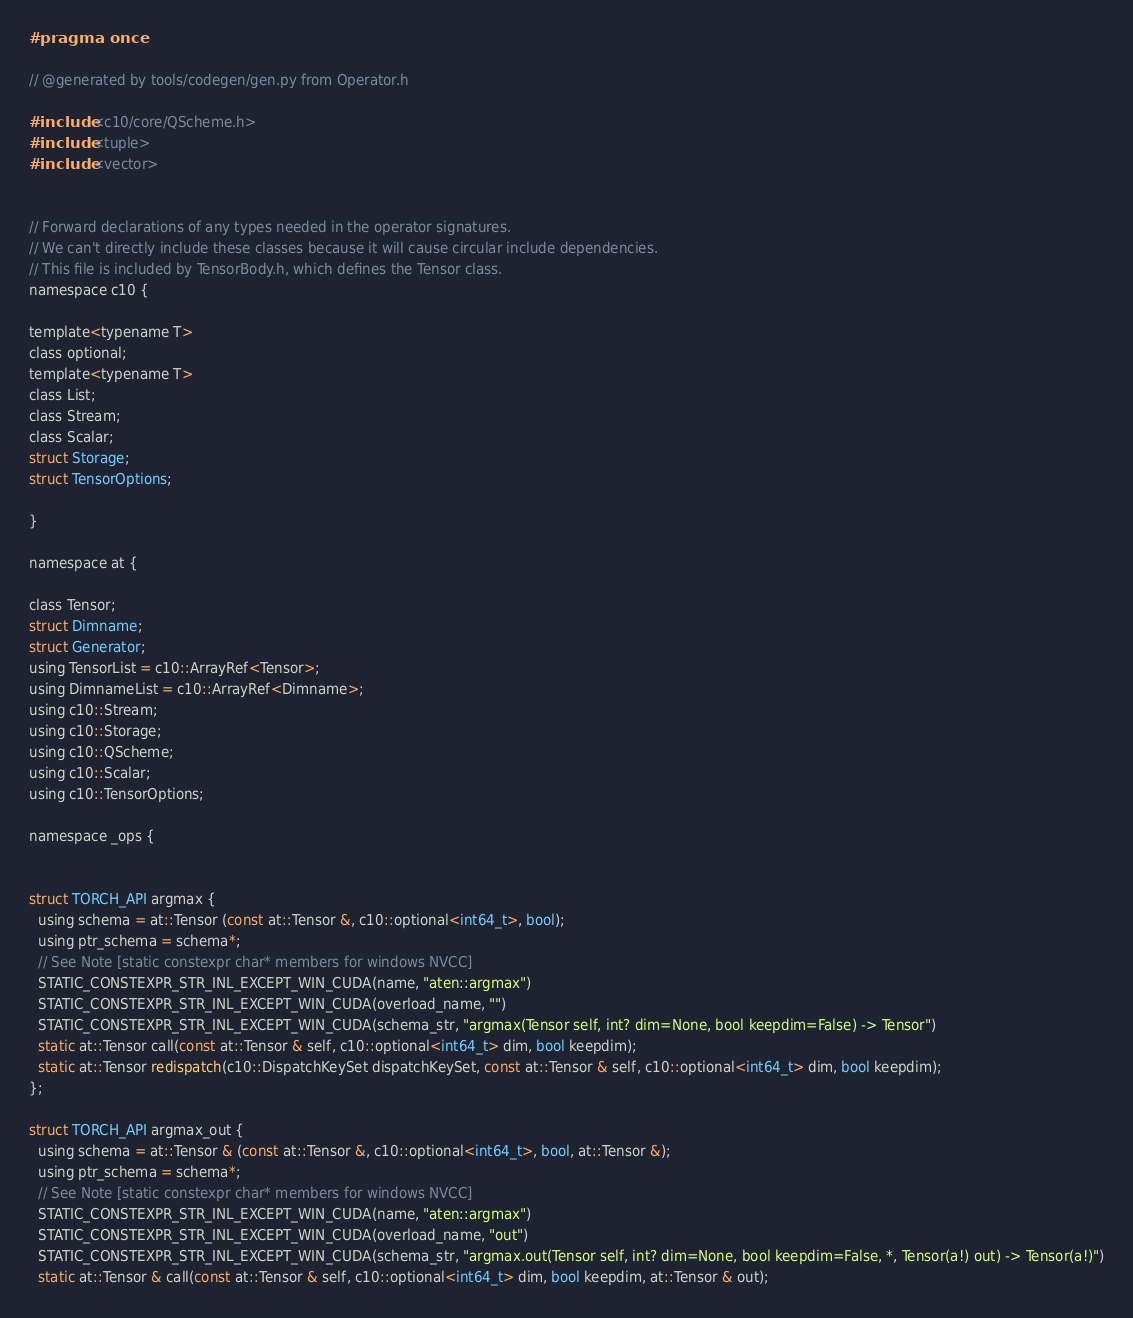Convert code to text. <code><loc_0><loc_0><loc_500><loc_500><_C_>#pragma once

// @generated by tools/codegen/gen.py from Operator.h

#include <c10/core/QScheme.h>
#include <tuple>
#include <vector>


// Forward declarations of any types needed in the operator signatures.
// We can't directly include these classes because it will cause circular include dependencies.
// This file is included by TensorBody.h, which defines the Tensor class.
namespace c10 {

template<typename T>
class optional;
template<typename T>
class List;
class Stream;
class Scalar;
struct Storage;
struct TensorOptions;

}

namespace at {

class Tensor;
struct Dimname;
struct Generator;
using TensorList = c10::ArrayRef<Tensor>;
using DimnameList = c10::ArrayRef<Dimname>;
using c10::Stream;
using c10::Storage;
using c10::QScheme;
using c10::Scalar;
using c10::TensorOptions;

namespace _ops {


struct TORCH_API argmax {
  using schema = at::Tensor (const at::Tensor &, c10::optional<int64_t>, bool);
  using ptr_schema = schema*;
  // See Note [static constexpr char* members for windows NVCC]
  STATIC_CONSTEXPR_STR_INL_EXCEPT_WIN_CUDA(name, "aten::argmax")
  STATIC_CONSTEXPR_STR_INL_EXCEPT_WIN_CUDA(overload_name, "")
  STATIC_CONSTEXPR_STR_INL_EXCEPT_WIN_CUDA(schema_str, "argmax(Tensor self, int? dim=None, bool keepdim=False) -> Tensor")
  static at::Tensor call(const at::Tensor & self, c10::optional<int64_t> dim, bool keepdim);
  static at::Tensor redispatch(c10::DispatchKeySet dispatchKeySet, const at::Tensor & self, c10::optional<int64_t> dim, bool keepdim);
};

struct TORCH_API argmax_out {
  using schema = at::Tensor & (const at::Tensor &, c10::optional<int64_t>, bool, at::Tensor &);
  using ptr_schema = schema*;
  // See Note [static constexpr char* members for windows NVCC]
  STATIC_CONSTEXPR_STR_INL_EXCEPT_WIN_CUDA(name, "aten::argmax")
  STATIC_CONSTEXPR_STR_INL_EXCEPT_WIN_CUDA(overload_name, "out")
  STATIC_CONSTEXPR_STR_INL_EXCEPT_WIN_CUDA(schema_str, "argmax.out(Tensor self, int? dim=None, bool keepdim=False, *, Tensor(a!) out) -> Tensor(a!)")
  static at::Tensor & call(const at::Tensor & self, c10::optional<int64_t> dim, bool keepdim, at::Tensor & out);</code> 